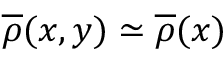<formula> <loc_0><loc_0><loc_500><loc_500>\overline { \rho } ( x , y ) \simeq \overline { \rho } ( x )</formula> 